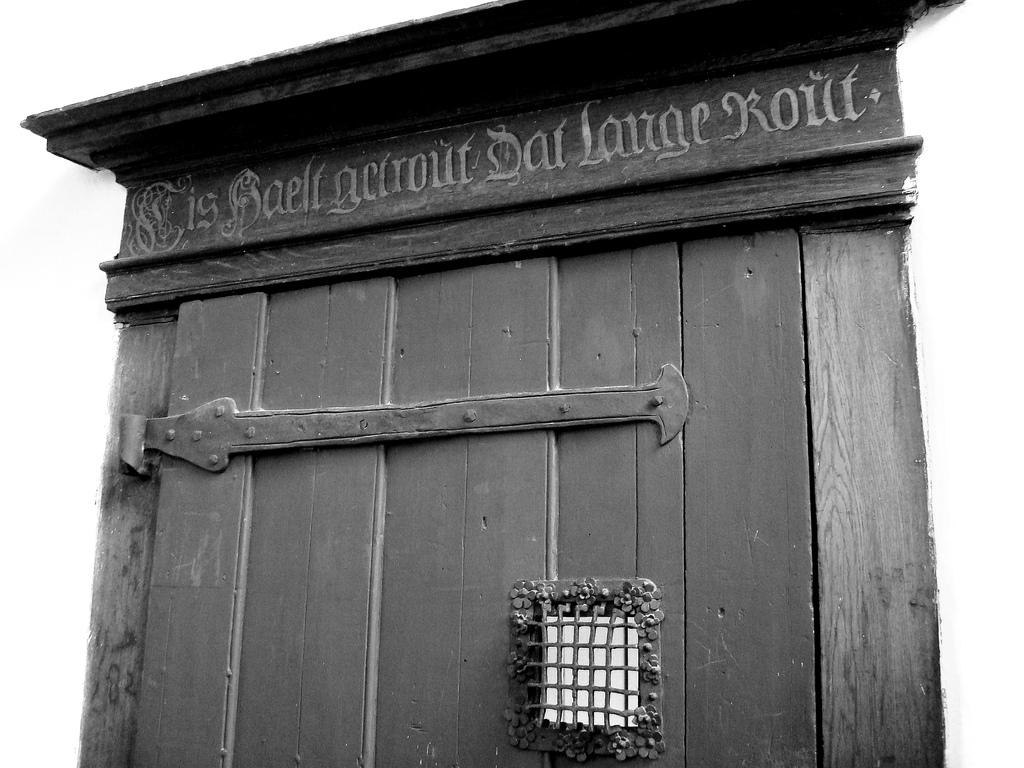What is a prominent feature in the image? There is a door in the image. What is attached to the door? There is a metal rod on the door. Is there any opening for light or ventilation in the image? Yes, there is a window in the image. What color is the curtain hanging in front of the window in the image? There is no curtain present in the image. How many flies can be seen buzzing around the door in the image? There are no flies visible in the image. 